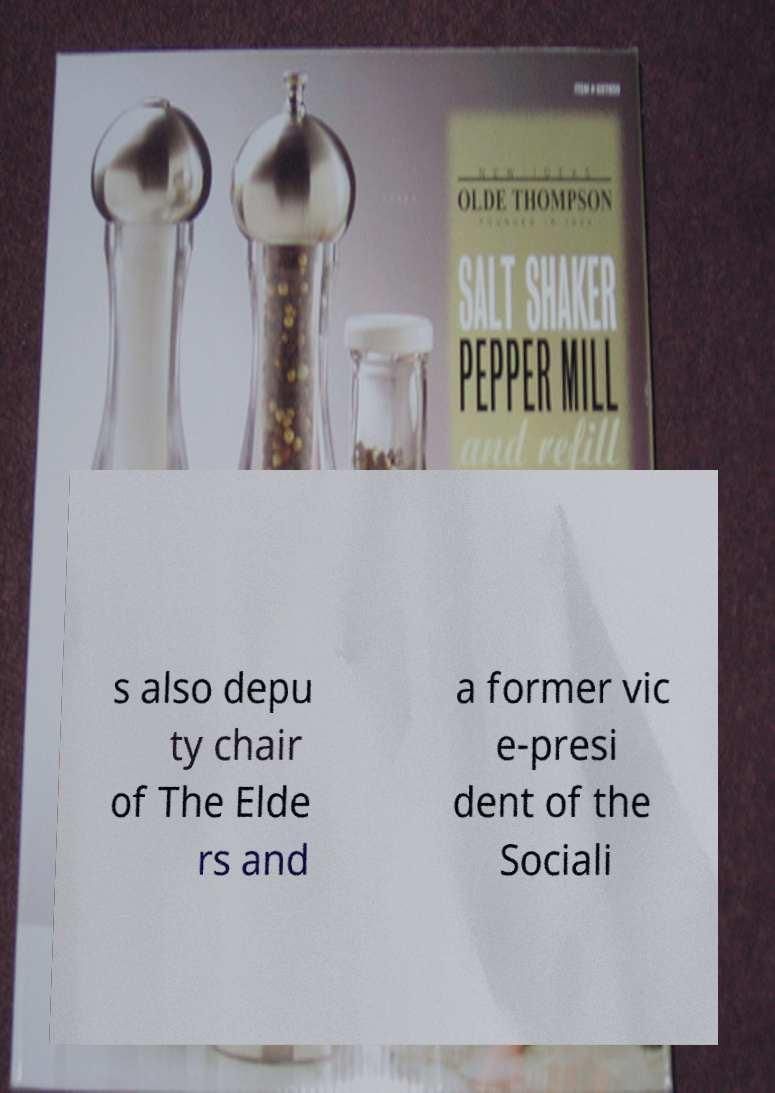I need the written content from this picture converted into text. Can you do that? s also depu ty chair of The Elde rs and a former vic e-presi dent of the Sociali 